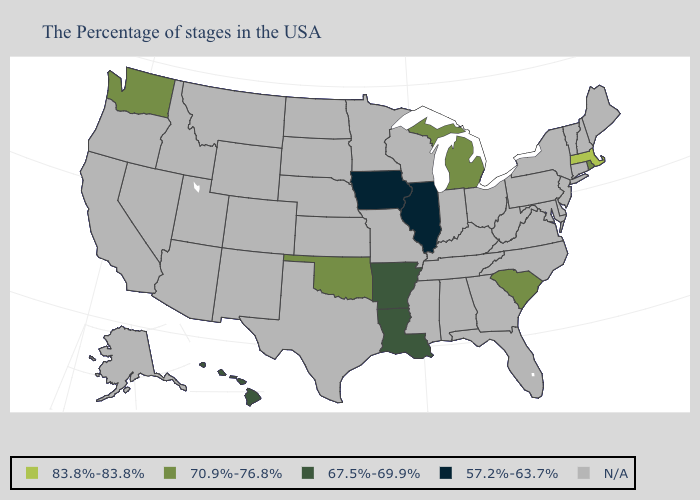What is the value of Washington?
Give a very brief answer. 70.9%-76.8%. What is the value of Minnesota?
Give a very brief answer. N/A. Which states have the lowest value in the West?
Short answer required. Hawaii. What is the value of Montana?
Quick response, please. N/A. Among the states that border Wisconsin , which have the highest value?
Give a very brief answer. Michigan. What is the lowest value in the West?
Short answer required. 67.5%-69.9%. Name the states that have a value in the range 67.5%-69.9%?
Quick response, please. Louisiana, Arkansas, Hawaii. What is the value of West Virginia?
Write a very short answer. N/A. What is the value of Nevada?
Keep it brief. N/A. Does the first symbol in the legend represent the smallest category?
Concise answer only. No. What is the value of North Dakota?
Short answer required. N/A. Does Illinois have the lowest value in the USA?
Quick response, please. Yes. How many symbols are there in the legend?
Write a very short answer. 5. 